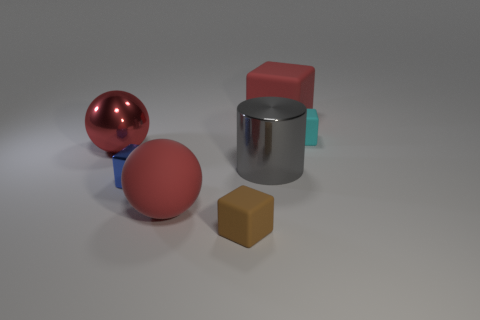Does the big matte block have the same color as the large rubber sphere?
Provide a short and direct response. Yes. What color is the tiny shiny block?
Make the answer very short. Blue. What shape is the big rubber thing that is the same color as the rubber ball?
Provide a short and direct response. Cube. Is there a big yellow shiny ball?
Your response must be concise. No. There is a blue object that is made of the same material as the large cylinder; what is its size?
Offer a terse response. Small. What is the shape of the red matte object in front of the matte object on the right side of the large block to the right of the brown rubber block?
Your answer should be compact. Sphere. Are there an equal number of red spheres behind the tiny cyan matte object and tiny red rubber cylinders?
Your answer should be very brief. Yes. There is a matte sphere that is the same color as the big rubber cube; what is its size?
Ensure brevity in your answer.  Large. Does the big gray thing have the same shape as the brown thing?
Offer a very short reply. No. What number of objects are small matte cubes that are in front of the small blue cube or objects?
Provide a succinct answer. 7. 